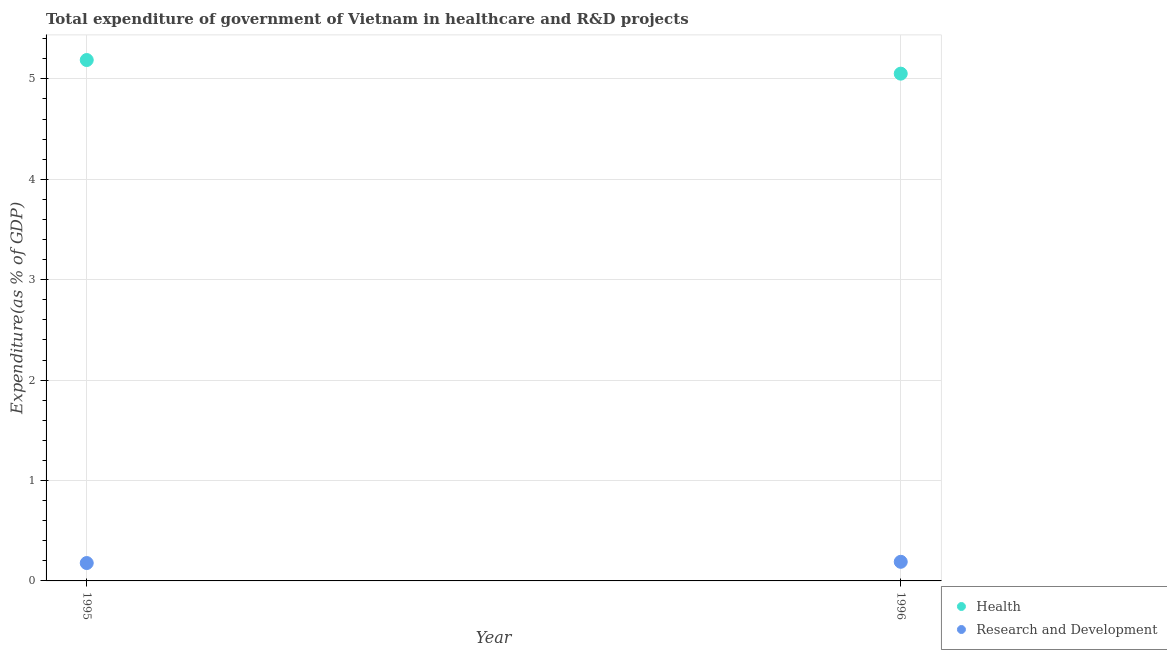How many different coloured dotlines are there?
Keep it short and to the point. 2. Is the number of dotlines equal to the number of legend labels?
Your response must be concise. Yes. What is the expenditure in healthcare in 1996?
Provide a short and direct response. 5.05. Across all years, what is the maximum expenditure in r&d?
Provide a succinct answer. 0.19. Across all years, what is the minimum expenditure in r&d?
Make the answer very short. 0.18. What is the total expenditure in r&d in the graph?
Provide a succinct answer. 0.37. What is the difference between the expenditure in r&d in 1995 and that in 1996?
Keep it short and to the point. -0.01. What is the difference between the expenditure in r&d in 1996 and the expenditure in healthcare in 1995?
Provide a succinct answer. -5. What is the average expenditure in healthcare per year?
Make the answer very short. 5.12. In the year 1995, what is the difference between the expenditure in r&d and expenditure in healthcare?
Offer a terse response. -5.01. What is the ratio of the expenditure in healthcare in 1995 to that in 1996?
Your answer should be very brief. 1.03. Is the expenditure in r&d in 1995 less than that in 1996?
Your response must be concise. Yes. Is the expenditure in healthcare strictly greater than the expenditure in r&d over the years?
Keep it short and to the point. Yes. What is the difference between two consecutive major ticks on the Y-axis?
Your answer should be very brief. 1. Are the values on the major ticks of Y-axis written in scientific E-notation?
Provide a short and direct response. No. How are the legend labels stacked?
Give a very brief answer. Vertical. What is the title of the graph?
Offer a very short reply. Total expenditure of government of Vietnam in healthcare and R&D projects. What is the label or title of the Y-axis?
Ensure brevity in your answer.  Expenditure(as % of GDP). What is the Expenditure(as % of GDP) of Health in 1995?
Give a very brief answer. 5.19. What is the Expenditure(as % of GDP) of Research and Development in 1995?
Ensure brevity in your answer.  0.18. What is the Expenditure(as % of GDP) of Health in 1996?
Ensure brevity in your answer.  5.05. What is the Expenditure(as % of GDP) in Research and Development in 1996?
Offer a very short reply. 0.19. Across all years, what is the maximum Expenditure(as % of GDP) of Health?
Provide a short and direct response. 5.19. Across all years, what is the maximum Expenditure(as % of GDP) of Research and Development?
Provide a succinct answer. 0.19. Across all years, what is the minimum Expenditure(as % of GDP) of Health?
Provide a short and direct response. 5.05. Across all years, what is the minimum Expenditure(as % of GDP) of Research and Development?
Offer a terse response. 0.18. What is the total Expenditure(as % of GDP) in Health in the graph?
Offer a terse response. 10.24. What is the total Expenditure(as % of GDP) in Research and Development in the graph?
Offer a very short reply. 0.37. What is the difference between the Expenditure(as % of GDP) of Health in 1995 and that in 1996?
Provide a short and direct response. 0.14. What is the difference between the Expenditure(as % of GDP) of Research and Development in 1995 and that in 1996?
Offer a very short reply. -0.01. What is the difference between the Expenditure(as % of GDP) of Health in 1995 and the Expenditure(as % of GDP) of Research and Development in 1996?
Give a very brief answer. 5. What is the average Expenditure(as % of GDP) of Health per year?
Keep it short and to the point. 5.12. What is the average Expenditure(as % of GDP) in Research and Development per year?
Provide a short and direct response. 0.18. In the year 1995, what is the difference between the Expenditure(as % of GDP) in Health and Expenditure(as % of GDP) in Research and Development?
Offer a very short reply. 5.01. In the year 1996, what is the difference between the Expenditure(as % of GDP) in Health and Expenditure(as % of GDP) in Research and Development?
Give a very brief answer. 4.86. What is the ratio of the Expenditure(as % of GDP) of Health in 1995 to that in 1996?
Make the answer very short. 1.03. What is the ratio of the Expenditure(as % of GDP) of Research and Development in 1995 to that in 1996?
Your response must be concise. 0.94. What is the difference between the highest and the second highest Expenditure(as % of GDP) in Health?
Provide a succinct answer. 0.14. What is the difference between the highest and the second highest Expenditure(as % of GDP) of Research and Development?
Offer a very short reply. 0.01. What is the difference between the highest and the lowest Expenditure(as % of GDP) in Health?
Give a very brief answer. 0.14. What is the difference between the highest and the lowest Expenditure(as % of GDP) of Research and Development?
Give a very brief answer. 0.01. 